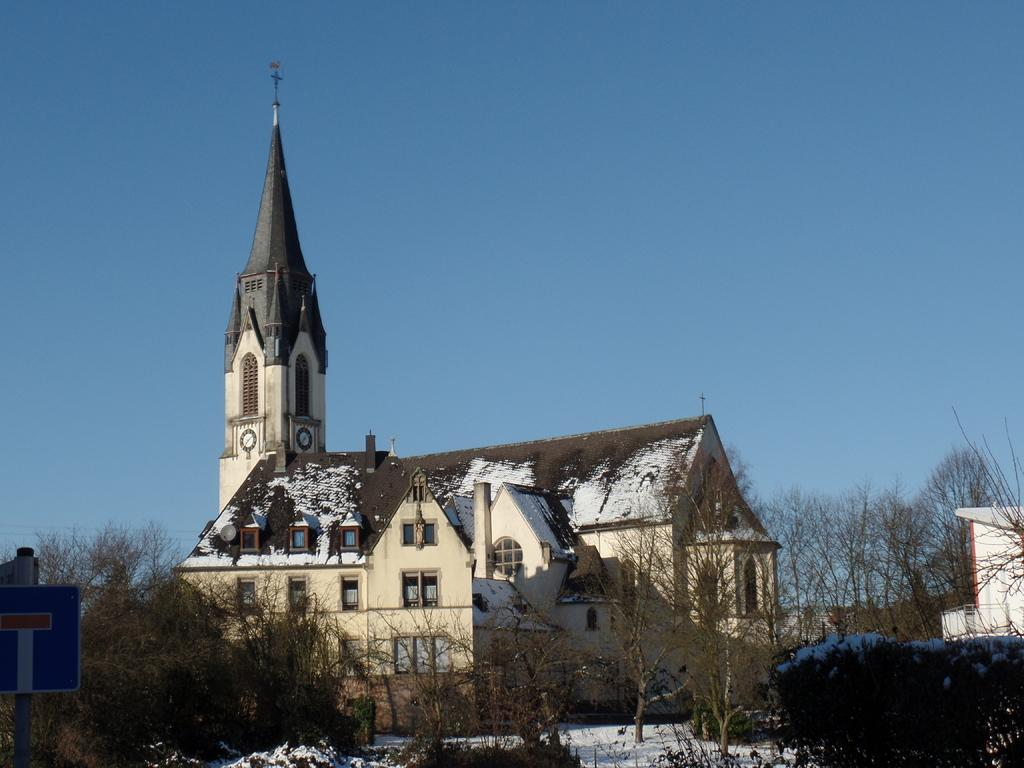What type of structures can be seen in the image? There are buildings in the image. the image. What other objects can be seen in the image besides buildings? There are poles, windows, a flag, trees, and a pole with a board on the left side of the image. Can you describe the weather conditions in the image? There is snow on the building roofs and on the ground, indicating a snowy environment. What is visible in the sky in the image? The sky is visible in the image. Where is the turkey located in the image? There is no turkey present in the image. What type of hall can be seen in the middle of the image? There is no hall present in the image. 